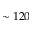Convert formula to latex. <formula><loc_0><loc_0><loc_500><loc_500>\sim 1 2 0</formula> 